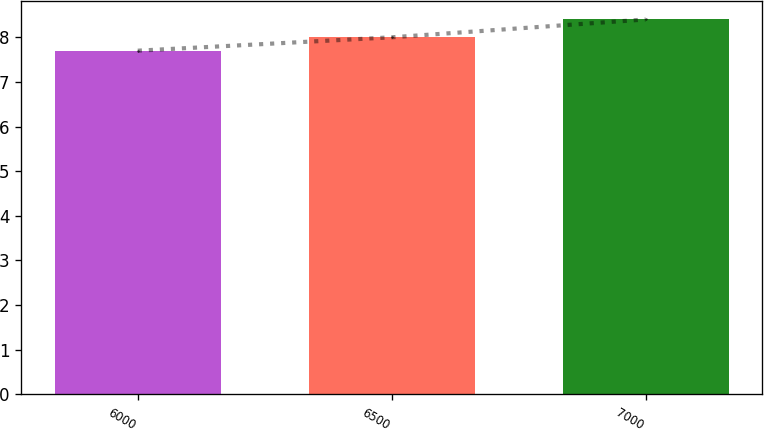Convert chart. <chart><loc_0><loc_0><loc_500><loc_500><bar_chart><fcel>6000<fcel>6500<fcel>7000<nl><fcel>7.7<fcel>8<fcel>8.4<nl></chart> 